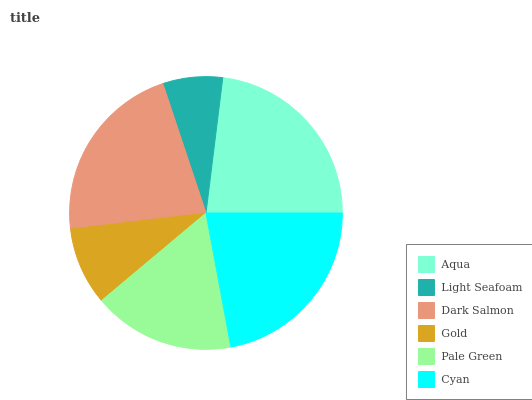Is Light Seafoam the minimum?
Answer yes or no. Yes. Is Aqua the maximum?
Answer yes or no. Yes. Is Dark Salmon the minimum?
Answer yes or no. No. Is Dark Salmon the maximum?
Answer yes or no. No. Is Dark Salmon greater than Light Seafoam?
Answer yes or no. Yes. Is Light Seafoam less than Dark Salmon?
Answer yes or no. Yes. Is Light Seafoam greater than Dark Salmon?
Answer yes or no. No. Is Dark Salmon less than Light Seafoam?
Answer yes or no. No. Is Dark Salmon the high median?
Answer yes or no. Yes. Is Pale Green the low median?
Answer yes or no. Yes. Is Cyan the high median?
Answer yes or no. No. Is Light Seafoam the low median?
Answer yes or no. No. 